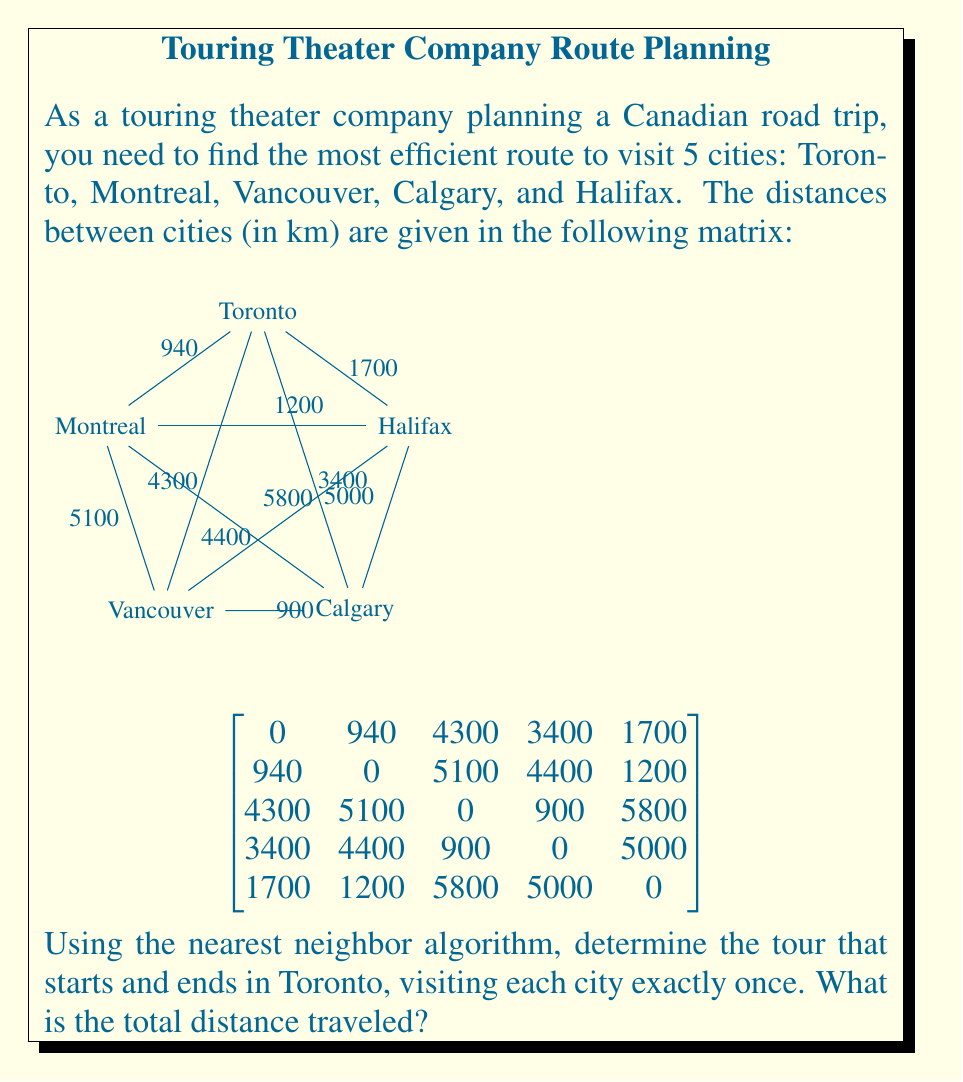Provide a solution to this math problem. Let's solve this step-by-step using the nearest neighbor algorithm:

1) Start in Toronto.

2) From Toronto, find the nearest unvisited city:
   Toronto to Montreal: 940 km
   Toronto to Vancouver: 4300 km
   Toronto to Calgary: 3400 km
   Toronto to Halifax: 1700 km
   The nearest is Montreal (940 km).

3) From Montreal, find the nearest unvisited city:
   Montreal to Vancouver: 5100 km
   Montreal to Calgary: 4400 km
   Montreal to Halifax: 1200 km
   The nearest is Halifax (1200 km).

4) From Halifax, find the nearest unvisited city:
   Halifax to Vancouver: 5800 km
   Halifax to Calgary: 5000 km
   The nearest is Calgary (5000 km).

5) From Calgary, the only unvisited city is Vancouver (900 km).

6) Finally, return to Toronto from Vancouver (4300 km).

The complete tour is:
Toronto → Montreal → Halifax → Calgary → Vancouver → Toronto

To calculate the total distance:
$$ 940 + 1200 + 5000 + 900 + 4300 = 12,340 \text{ km} $$
Answer: 12,340 km 